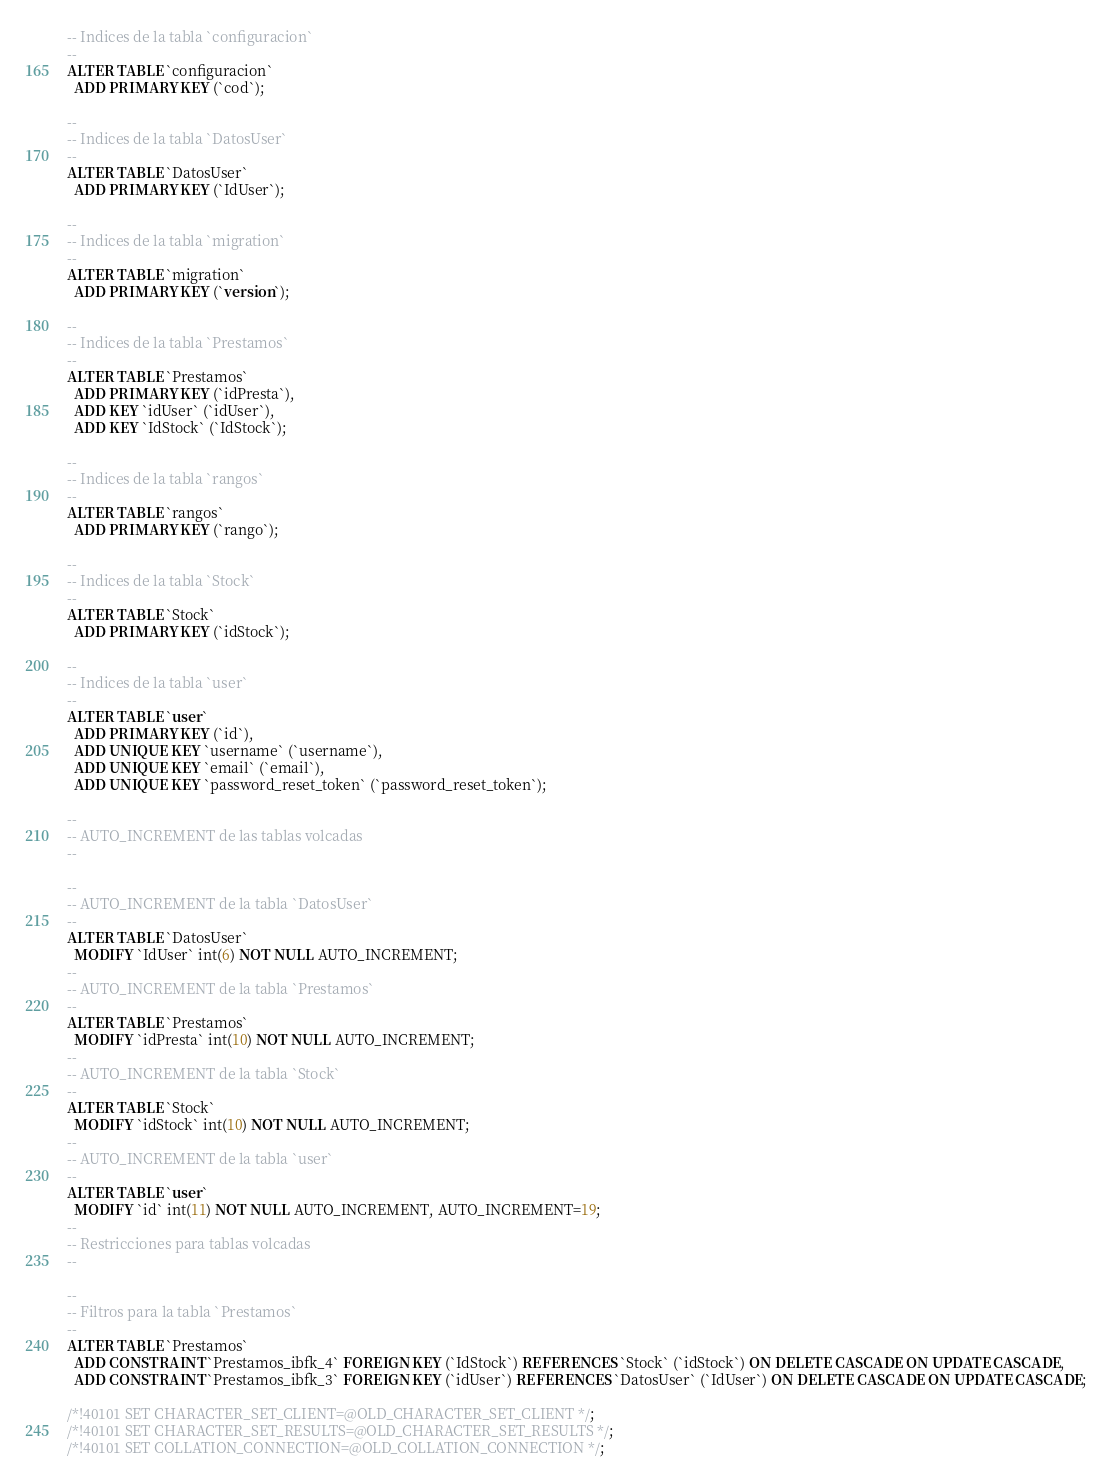<code> <loc_0><loc_0><loc_500><loc_500><_SQL_>-- Indices de la tabla `configuracion`
--
ALTER TABLE `configuracion`
  ADD PRIMARY KEY (`cod`);

--
-- Indices de la tabla `DatosUser`
--
ALTER TABLE `DatosUser`
  ADD PRIMARY KEY (`IdUser`);

--
-- Indices de la tabla `migration`
--
ALTER TABLE `migration`
  ADD PRIMARY KEY (`version`);

--
-- Indices de la tabla `Prestamos`
--
ALTER TABLE `Prestamos`
  ADD PRIMARY KEY (`idPresta`),
  ADD KEY `idUser` (`idUser`),
  ADD KEY `IdStock` (`IdStock`);

--
-- Indices de la tabla `rangos`
--
ALTER TABLE `rangos`
  ADD PRIMARY KEY (`rango`);

--
-- Indices de la tabla `Stock`
--
ALTER TABLE `Stock`
  ADD PRIMARY KEY (`idStock`);

--
-- Indices de la tabla `user`
--
ALTER TABLE `user`
  ADD PRIMARY KEY (`id`),
  ADD UNIQUE KEY `username` (`username`),
  ADD UNIQUE KEY `email` (`email`),
  ADD UNIQUE KEY `password_reset_token` (`password_reset_token`);

--
-- AUTO_INCREMENT de las tablas volcadas
--

--
-- AUTO_INCREMENT de la tabla `DatosUser`
--
ALTER TABLE `DatosUser`
  MODIFY `IdUser` int(6) NOT NULL AUTO_INCREMENT;
--
-- AUTO_INCREMENT de la tabla `Prestamos`
--
ALTER TABLE `Prestamos`
  MODIFY `idPresta` int(10) NOT NULL AUTO_INCREMENT;
--
-- AUTO_INCREMENT de la tabla `Stock`
--
ALTER TABLE `Stock`
  MODIFY `idStock` int(10) NOT NULL AUTO_INCREMENT;
--
-- AUTO_INCREMENT de la tabla `user`
--
ALTER TABLE `user`
  MODIFY `id` int(11) NOT NULL AUTO_INCREMENT, AUTO_INCREMENT=19;
--
-- Restricciones para tablas volcadas
--

--
-- Filtros para la tabla `Prestamos`
--
ALTER TABLE `Prestamos`
  ADD CONSTRAINT `Prestamos_ibfk_4` FOREIGN KEY (`IdStock`) REFERENCES `Stock` (`idStock`) ON DELETE CASCADE ON UPDATE CASCADE,
  ADD CONSTRAINT `Prestamos_ibfk_3` FOREIGN KEY (`idUser`) REFERENCES `DatosUser` (`IdUser`) ON DELETE CASCADE ON UPDATE CASCADE;

/*!40101 SET CHARACTER_SET_CLIENT=@OLD_CHARACTER_SET_CLIENT */;
/*!40101 SET CHARACTER_SET_RESULTS=@OLD_CHARACTER_SET_RESULTS */;
/*!40101 SET COLLATION_CONNECTION=@OLD_COLLATION_CONNECTION */;
</code> 